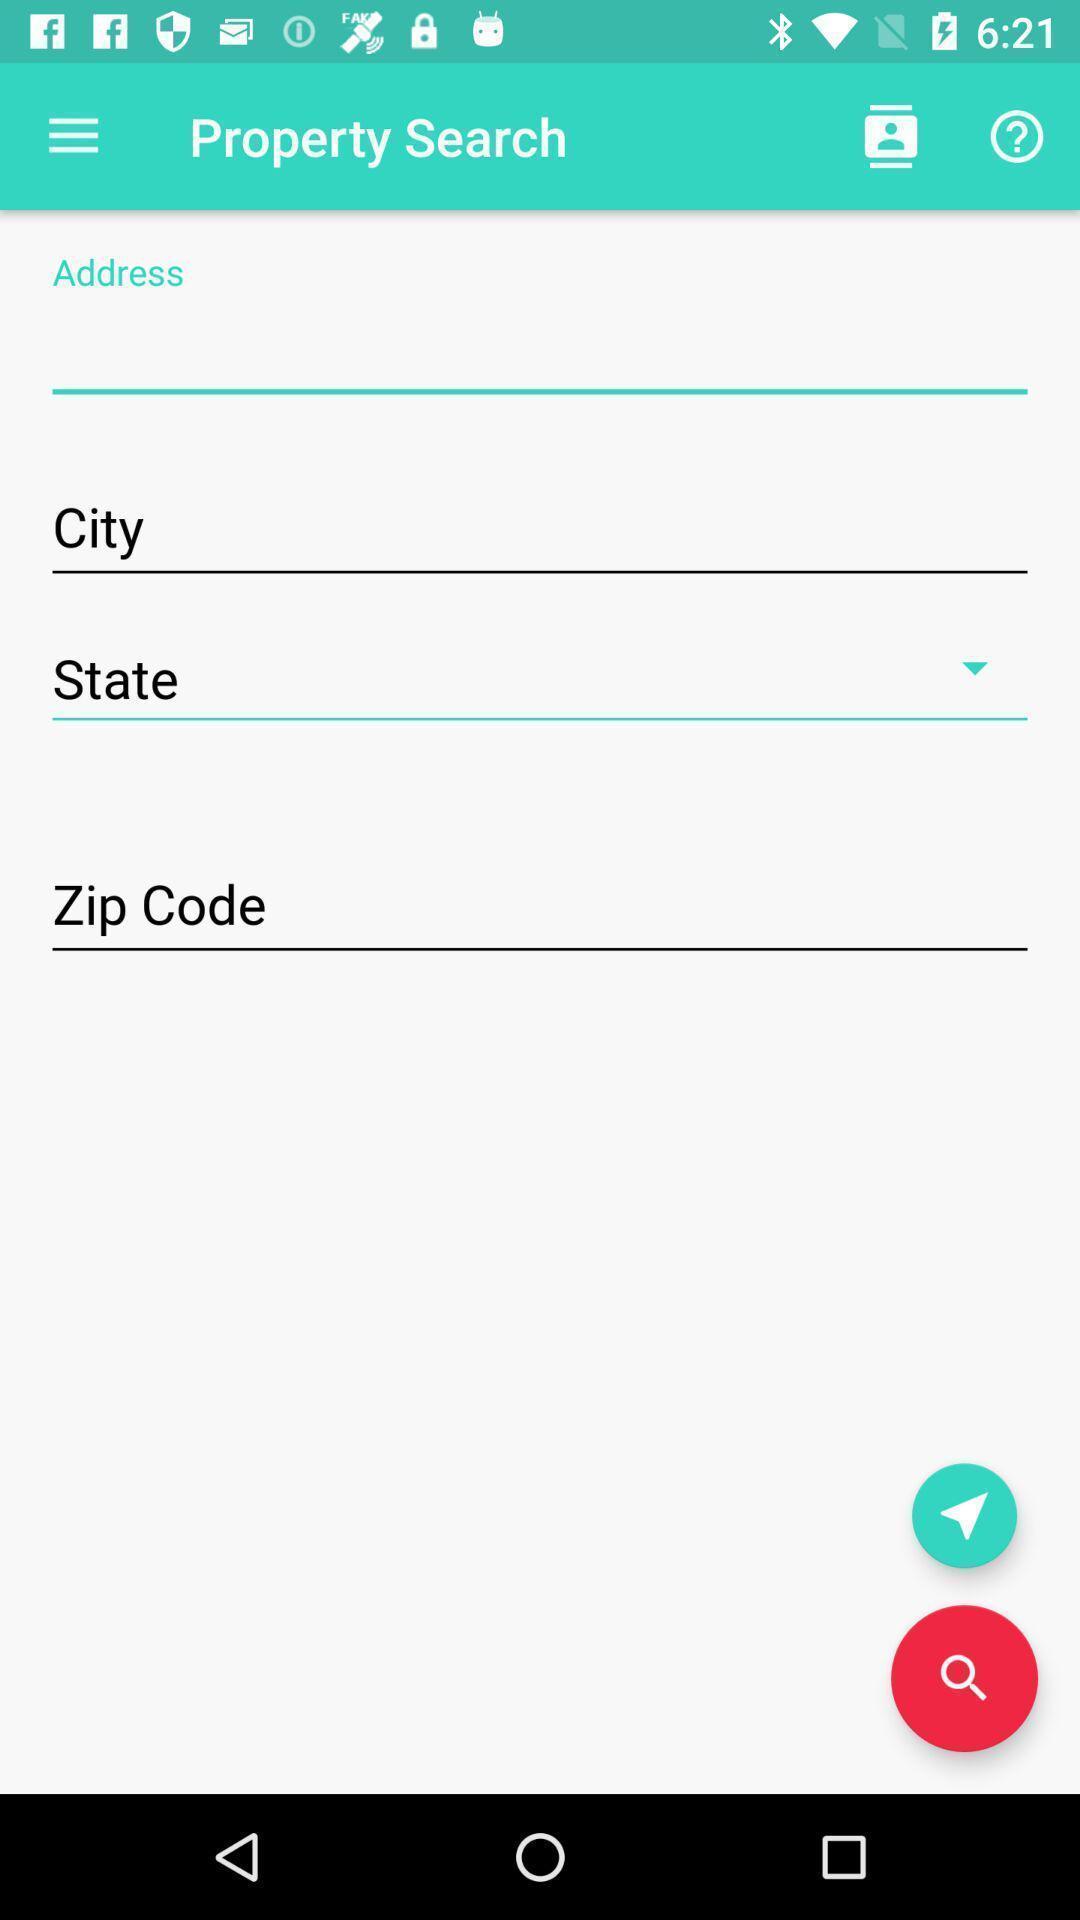Summarize the main components in this picture. Search page for searching a property. 